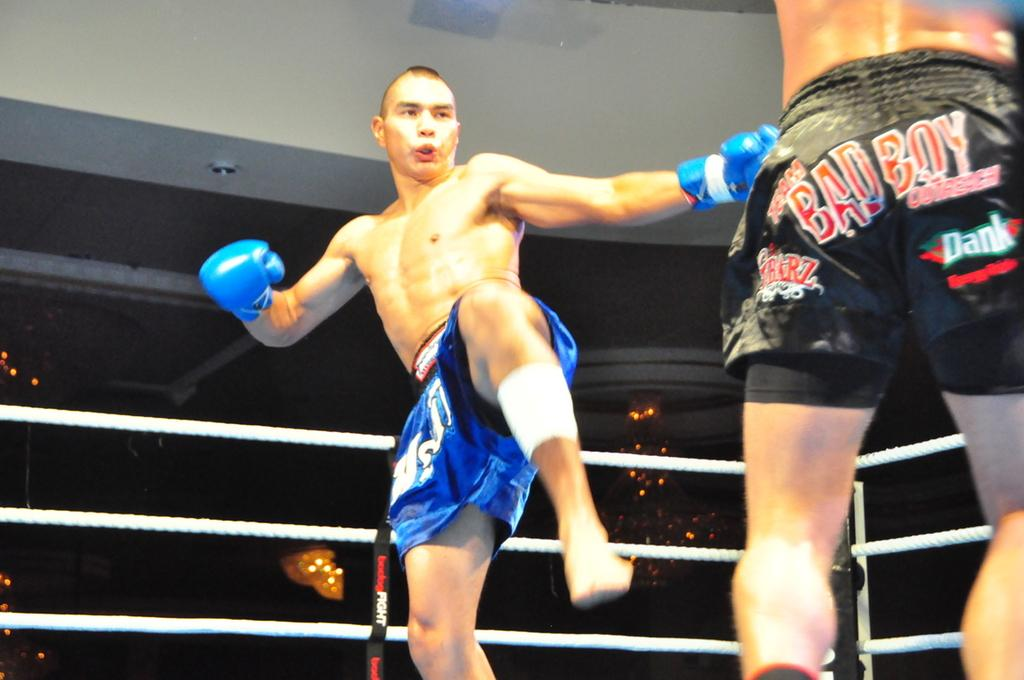<image>
Share a concise interpretation of the image provided. The person in the black shorts is a bad boy. 